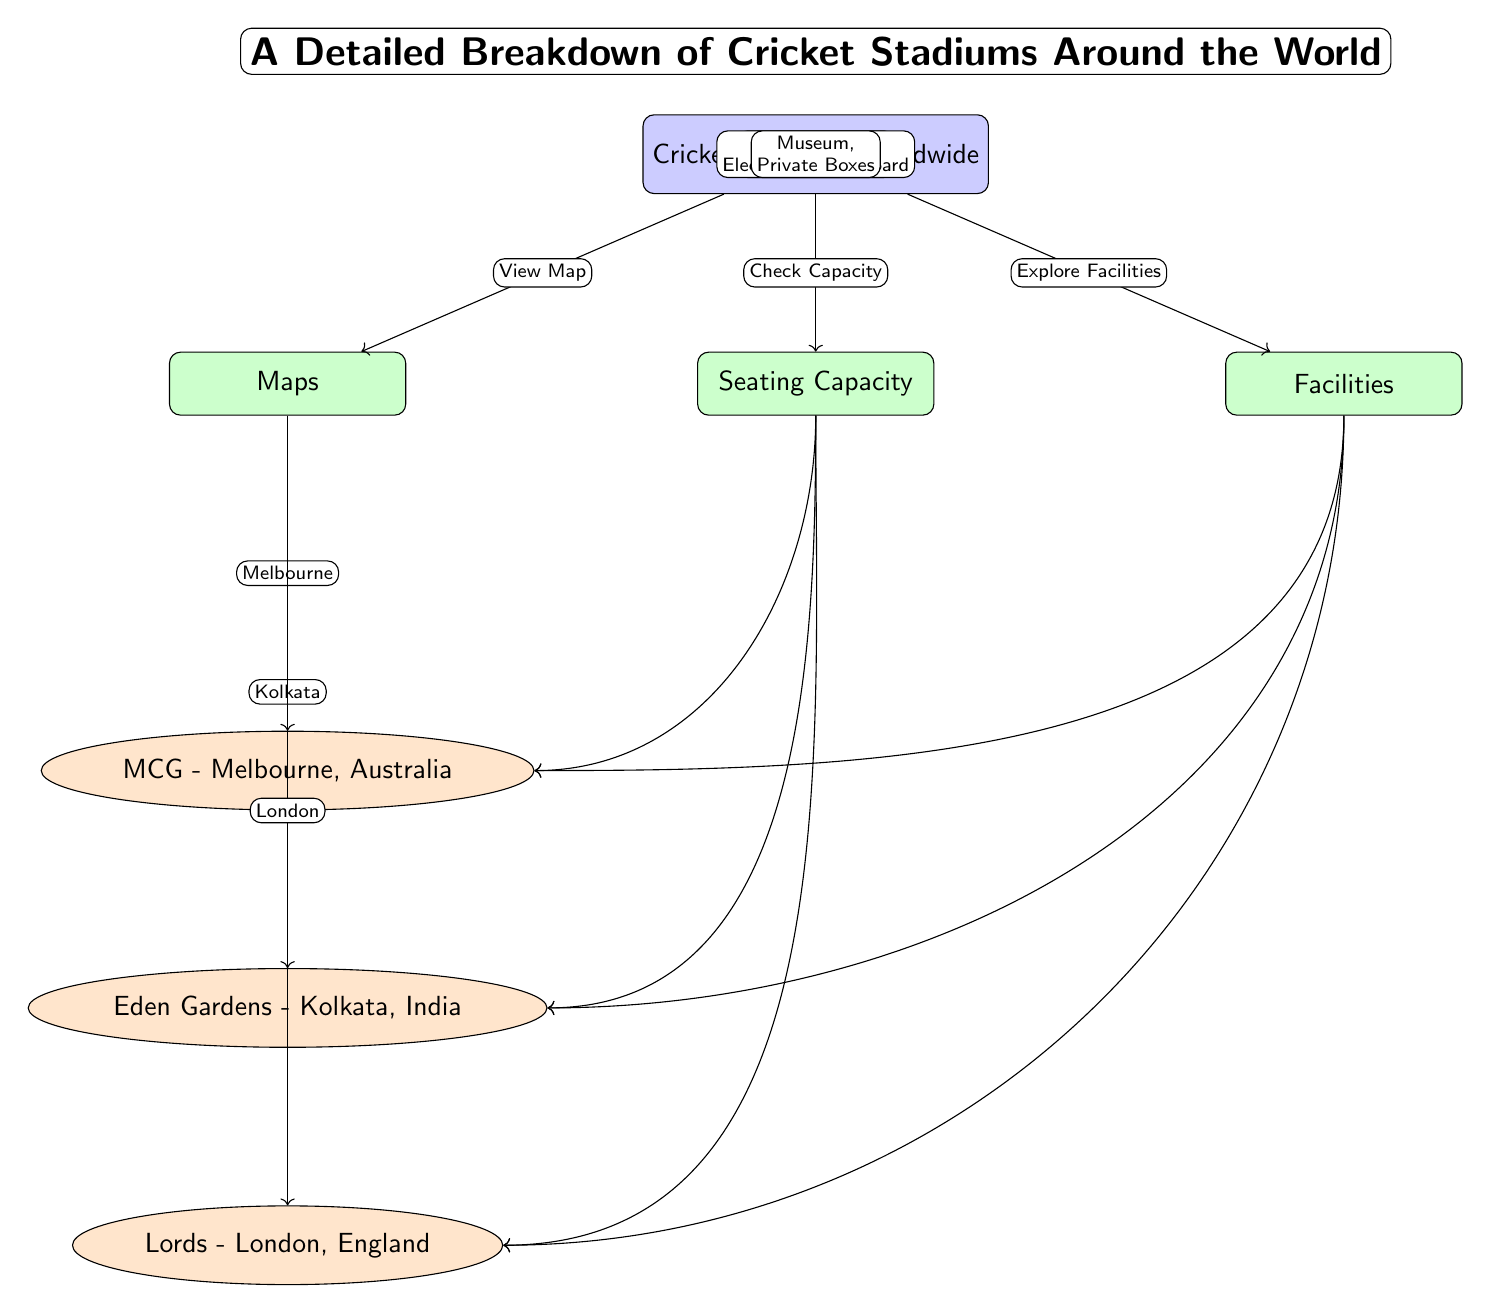What are the names of the three stadiums listed in the diagram? The diagram presents three stadiums: MCG in Melbourne, Eden Gardens in Kolkata, and Lords in London. These names are mentioned clearly as nodes connected to the category of Maps.
Answer: MCG, Eden Gardens, Lords What is the seating capacity of the MCG? The diagram indicates the seating capacity of the MCG through an edge labeled "100,024," connecting the capacity category and the MCG stadium node.
Answer: 100,024 Which stadium has the smallest seating capacity? The edges from the capacity category to each stadium show that Lords has a seating capacity of 30,000, which is less than the 66,349 of Eden Gardens and 100,024 of MCG. Thus, Lords has the smallest capacity.
Answer: Lords What type of facilities does Eden Gardens provide? The facilities connected to Eden Gardens in the diagram include a Media Centre and Electronic Scoreboard. These are specifically listed in the arrow leading from the facilities category.
Answer: Media Centre, Electronic Scoreboard How many stadiums are detailed in this diagram? The main node is connected to three different stadium nodes, which are MCG, Eden Gardens, and Lords. By counting these connections, we establish the total number of stadiums represented in the diagram.
Answer: 3 What facilities does the MCG offer? The facilities specified for MCG in the diagram include Corporate Boxes and Practice Nets. The details can be found from the facilities category leading to the MCG.
Answer: Corporate Boxes, Practice Nets Which city is associated with Lords? In the diagram, the arrow from the maps category to the Lords stadium node indicates that it is associated with London, as stated in the label for that edge.
Answer: London What is the flow direction from the main node to categories? The main node "Cricket Stadiums Worldwide" connects to three categories (Maps, Seating Capacity, Facilities) in a downward direction, each depicting a specific aspect of the stadiums. The edges show clearly the relationship.
Answer: Downwards 